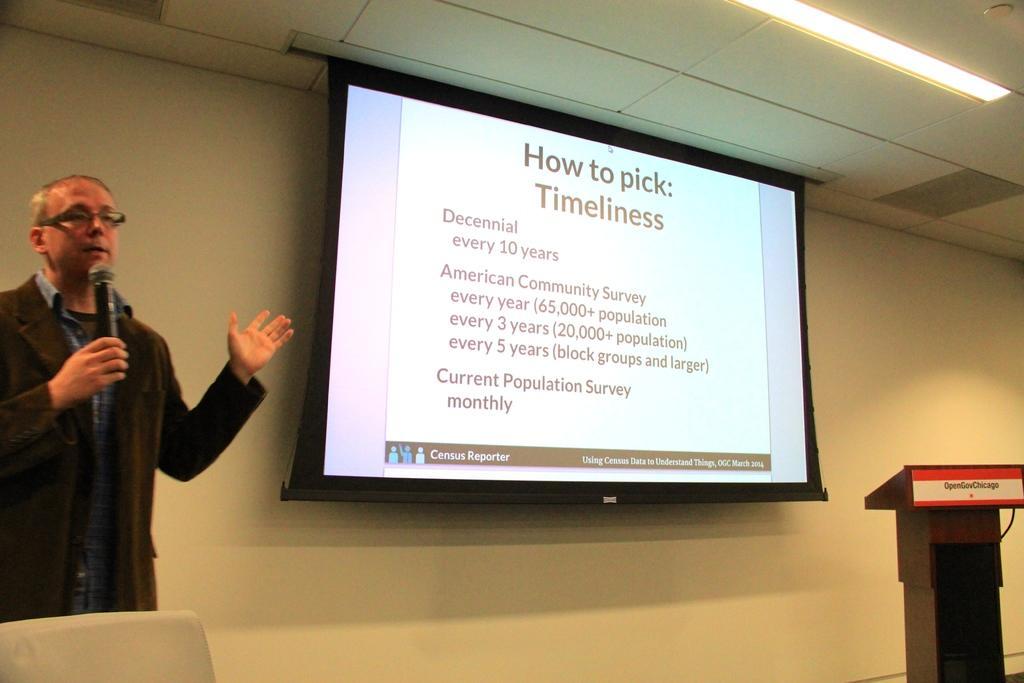Please provide a concise description of this image. On the left side a man is standing and holding a mic in his hand and in front of him there is a chair. In the background we can see wall, screen and a light on the ceiling and there is a podium on the right side. 